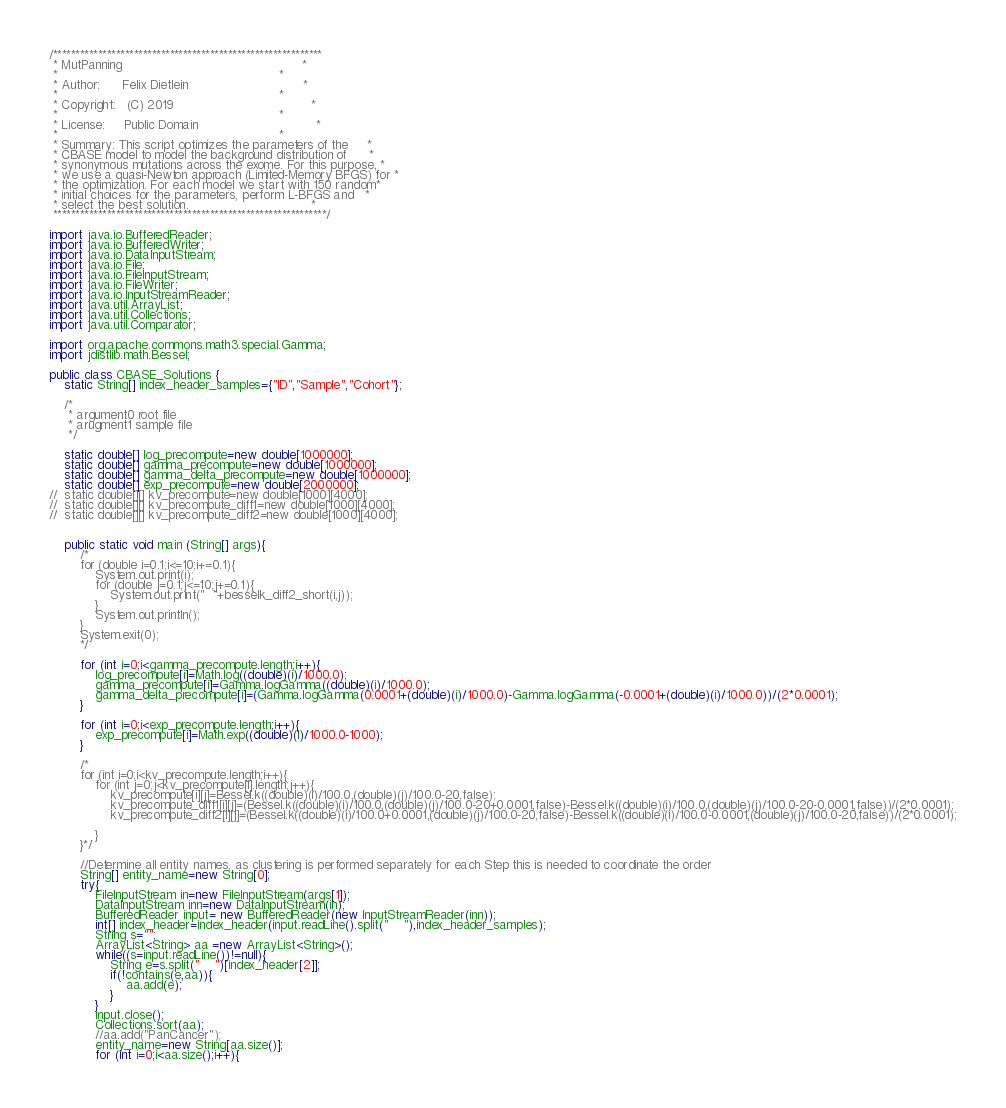<code> <loc_0><loc_0><loc_500><loc_500><_Java_>/************************************************************           
 * MutPanning 												*
 * 															*   
 * Author:		Felix Dietlein								*   
 *															*   
 * Copyright:	(C) 2019 									*   
 *															*   
 * License:		Public Domain								*   
 *															*   
 * Summary: This script optimizes the parameters of the 	*
 * CBASE model to model the background distribution of		*
 * synonymous mutations across the exome. For this purpose,	*
 * we use a quasi-Newton approach (Limited-Memory BFGS) for	*
 * the optimization. For each model we start with 150 random*   
 * initial choices for the parameters, perform L-BFGS and 	*
 * select the best solution.								*
 *************************************************************/

import java.io.BufferedReader;
import java.io.BufferedWriter;
import java.io.DataInputStream;
import java.io.File;
import java.io.FileInputStream;
import java.io.FileWriter;
import java.io.InputStreamReader;
import java.util.ArrayList;
import java.util.Collections;
import java.util.Comparator;

import org.apache.commons.math3.special.Gamma;
import jdistlib.math.Bessel;

public class CBASE_Solutions {
	static String[] index_header_samples={"ID","Sample","Cohort"};
	
	/*
	 * argument0 root file
	 * arugment1 sample file
	 */
	
	static double[] log_precompute=new double[1000000];
	static double[] gamma_precompute=new double[1000000];
	static double[] gamma_delta_precompute=new double[1000000];
	static double[] exp_precompute=new double[2000000];
//	static double[][] kv_precompute=new double[1000][4000];
//	static double[][] kv_precompute_diff1=new double[1000][4000];
//	static double[][] kv_precompute_diff2=new double[1000][4000];
	
	
	public static void main (String[] args){
		/*
		for (double i=0.1;i<=10;i+=0.1){
			System.out.print(i);
			for (double j=0.1;j<=10;j+=0.1){
				System.out.print("	"+besselk_diff2_short(i,j));
			}
			System.out.println();
		}
		System.exit(0);
		*/
		
		for (int i=0;i<gamma_precompute.length;i++){
			log_precompute[i]=Math.log((double)(i)/1000.0);
			gamma_precompute[i]=Gamma.logGamma((double)(i)/1000.0);
			gamma_delta_precompute[i]=(Gamma.logGamma(0.0001+(double)(i)/1000.0)-Gamma.logGamma(-0.0001+(double)(i)/1000.0))/(2*0.0001);
		}
		
		for (int i=0;i<exp_precompute.length;i++){
			exp_precompute[i]=Math.exp((double)(i)/1000.0-1000);
		}
	
		/*
		for (int i=0;i<kv_precompute.length;i++){
			for (int j=0;j<kv_precompute[i].length;j++){
				kv_precompute[i][j]=Bessel.k((double)(i)/100.0,(double)(j)/100.0-20,false);
				kv_precompute_diff1[i][j]=(Bessel.k((double)(i)/100.0,(double)(j)/100.0-20+0.0001,false)-Bessel.k((double)(i)/100.0,(double)(j)/100.0-20-0.0001,false))/(2*0.0001);
				kv_precompute_diff2[i][j]=(Bessel.k((double)(i)/100.0+0.0001,(double)(j)/100.0-20,false)-Bessel.k((double)(i)/100.0-0.0001,(double)(j)/100.0-20,false))/(2*0.0001);
				
			}
		}*/
		
		//Determine all entity names, as clustering is performed separately for each Step this is needed to coordinate the order
		String[] entity_name=new String[0];
		try{
			FileInputStream in=new FileInputStream(args[1]);
			DataInputStream inn=new DataInputStream(in);
			BufferedReader input= new BufferedReader(new InputStreamReader(inn));
			int[] index_header=index_header(input.readLine().split("	"),index_header_samples);
			String s="";
			ArrayList<String> aa =new ArrayList<String>();
			while((s=input.readLine())!=null){
				String e=s.split("	")[index_header[2]];
				if(!contains(e,aa)){
					aa.add(e);
				}
			}
			input.close();
			Collections.sort(aa);
			//aa.add("PanCancer");
			entity_name=new String[aa.size()];
			for (int i=0;i<aa.size();i++){</code> 